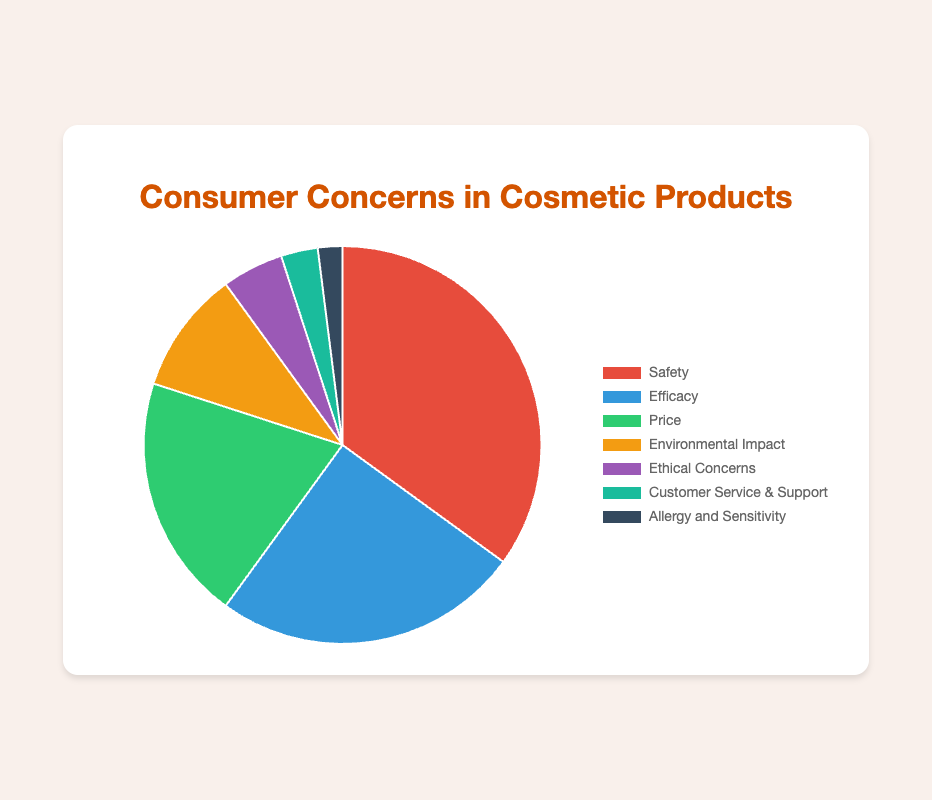Which concern holds the largest percentage? By observing the pie chart, the concern with the largest section corresponds to Safety, which occupies the biggest portion of the pie.
Answer: Safety Which concern holds the smallest percentage? The smallest section of the pie chart is associated with Allergy and Sensitivity, as it has the lowest percentage.
Answer: Allergy and Sensitivity What percentage of consumers are concerned about Price and Environmental Impact combined? Adding the percentages for Price (20%) and Environmental Impact (10%) gives us the combined percentage: 20% + 10% = 30%.
Answer: 30% What is the difference in percentage between concerns for Safety and Customer Service & Support? The difference is calculated by subtracting the percentage of Customer Service & Support (3%) from Safety (35%): 35% - 3% = 32%.
Answer: 32% How do concerns about Ethical Concerns compare to those about Customer Service & Support? Ethical Concerns are greater than Customer Service & Support by a margin of 2%, with Ethical Concerns at 5% and Customer Service & Support at 3%.
Answer: Ethical Concerns are higher by 2% What fraction of the total concerns are about Safety, Efficacy, and Price combined? First, sum up the percentages of Safety, Efficacy, and Price: 35% + 25% + 20% = 80%. Therefore, 80 out of the total 100% relates to those three concerns, so the fraction is 80/100.
Answer: 4/5 Which concerns are represented by colors in the blue spectrum (e.g., blue, green)? Observing the color assignment in the chart, Efficacy is represented in blue, and Ethical Concerns is represented in green tones. These correspond to Efficacy (25%) and Ethical Concerns (5%).
Answer: Efficacy and Ethical Concerns What's the total percentage for the categories with concerns less than 10%? Summing the percentages for Environmental Impact (10%, exactly at the limit), Ethical Concerns (5%), Customer Service & Support (3%), and Allergy and Sensitivity (2%) gives: 10% + 5% + 3% + 2% = 20%.
Answer: 20% By how much does the percentage for Efficacy exceed that for Price? Subtract the percentage for Price (20%) from Efficacy (25%): 25% - 20% = 5%.
Answer: 5% 